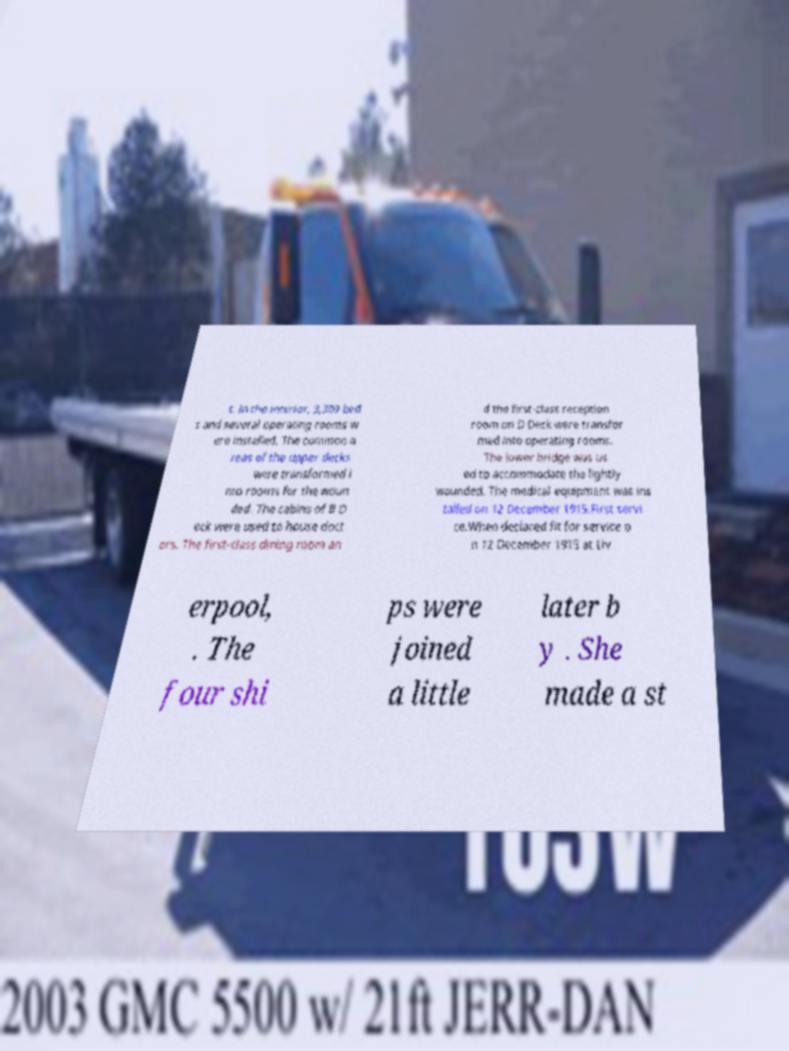Could you extract and type out the text from this image? t. In the interior, 3,309 bed s and several operating rooms w ere installed. The common a reas of the upper decks were transformed i nto rooms for the woun ded. The cabins of B D eck were used to house doct ors. The first-class dining room an d the first-class reception room on D Deck were transfor med into operating rooms. The lower bridge was us ed to accommodate the lightly wounded. The medical equipment was ins talled on 12 December 1915.First servi ce.When declared fit for service o n 12 December 1915 at Liv erpool, . The four shi ps were joined a little later b y . She made a st 